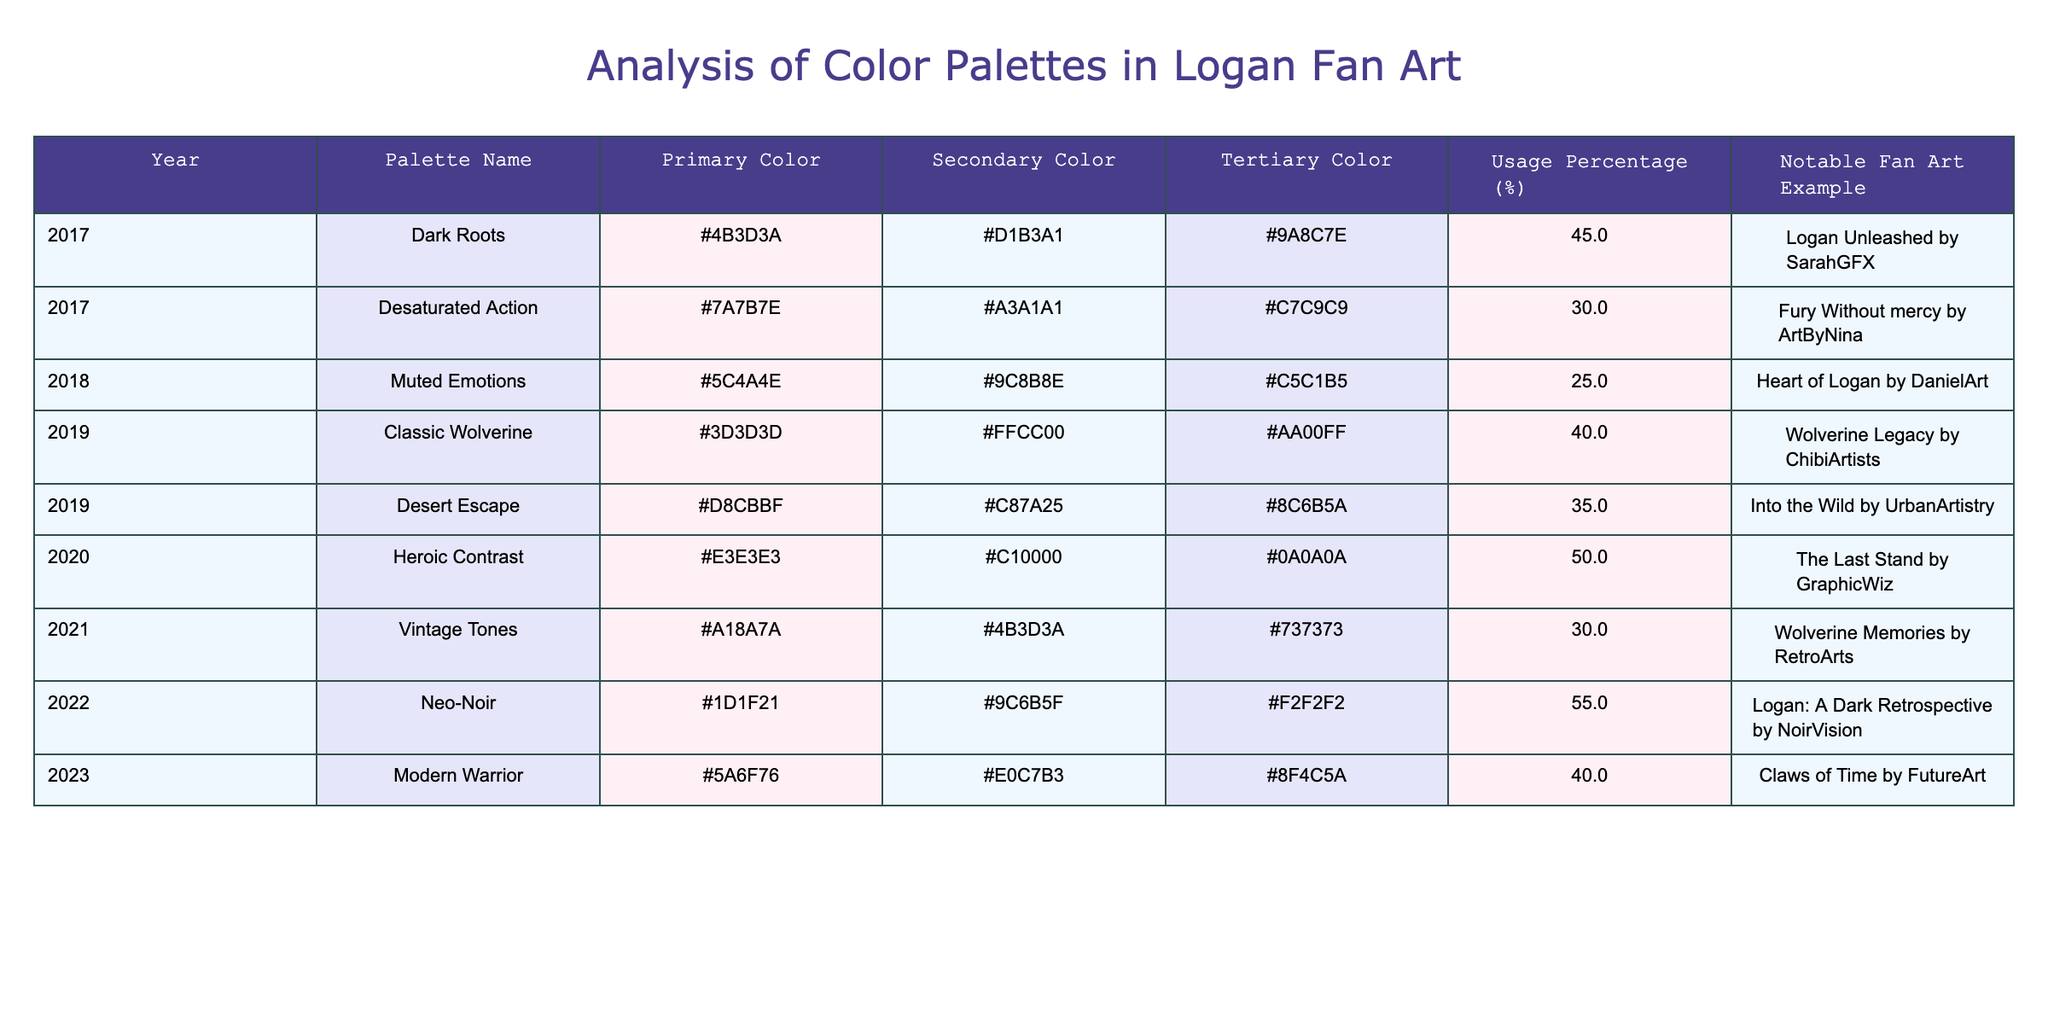What year had the palette with the highest usage percentage? By inspecting the "Usage Percentage (%)" column, the highest value is 55%, which corresponds to the year 2022 under the palette "Neo-Noir."
Answer: 2022 Which palette in 2019 had a tertiary color that is an orange shade? Looking at the 2019 rows, "Desert Escape" has a tertiary color with the code #8C6B5A, which can be interpreted as an orange shade.
Answer: Desert Escape What is the average usage percentage of palettes used from 2017 to 2019? The usage percentages for those years are 45, 30, 25, 40, and 35. Adding these gives 205. There are 5 values, so the average is 205/5 = 41.
Answer: 41 Did any palette in 2020 have a secondary color that is red? In the 2020 row, "Heroic Contrast" has a secondary color denoted by #C10000, which is a shade of red.
Answer: Yes Which year had both the highest primary color and the highest secondary color value? The color codes for primary in 2022 is #1D1F21 (dark), and for secondary is #9C6B5F (dull). The year 2020 "Heroic Contrast" had a primary color of #E3E3E3 (light) and secondary color #C10000 (red), which both are higher in visual vibrancy compared to the other years. Therefore, 2020 holds the highest primary and secondary color values among all years.
Answer: 2020 